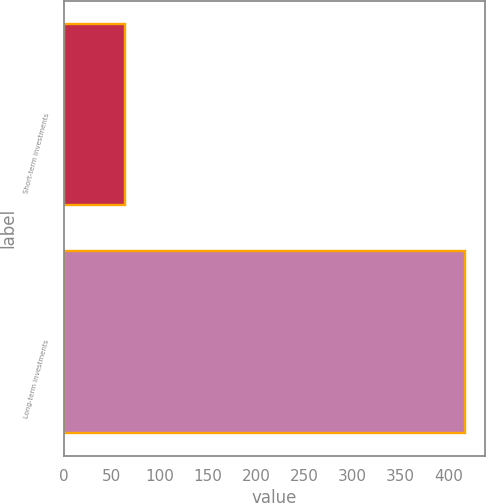Convert chart to OTSL. <chart><loc_0><loc_0><loc_500><loc_500><bar_chart><fcel>Short-term investments<fcel>Long-term investments<nl><fcel>64<fcel>417<nl></chart> 